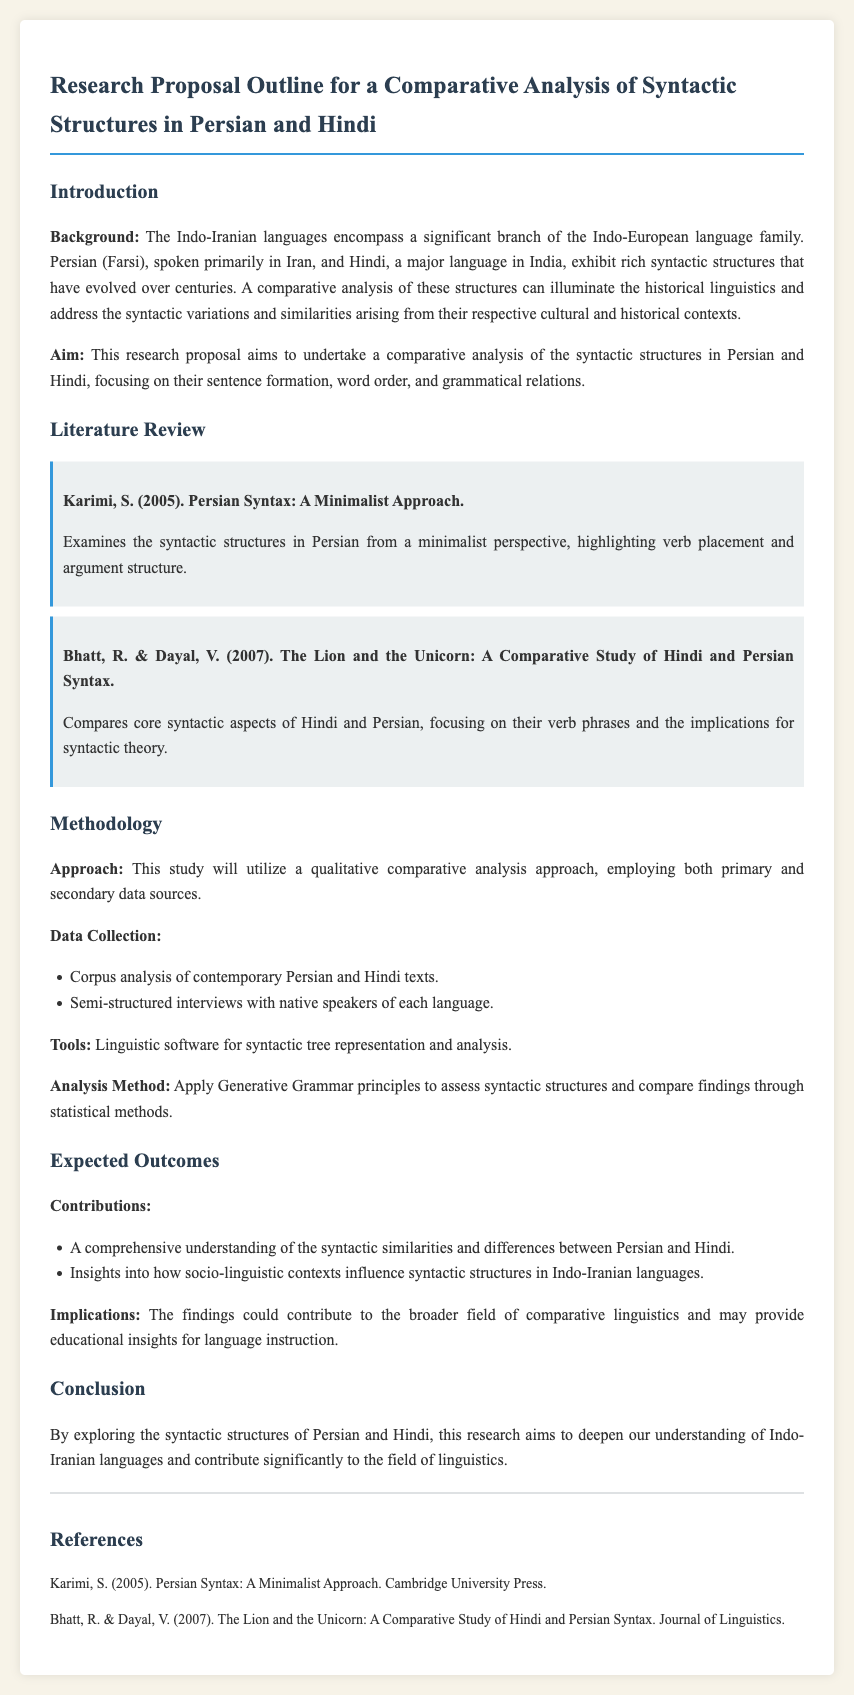What is the primary focus of the research proposal? The research proposal aims to undertake a comparative analysis of the syntactic structures in Persian and Hindi, focusing on their sentence formation, word order, and grammatical relations.
Answer: comparative analysis of the syntactic structures in Persian and Hindi Who authored the key study on Persian syntax from a minimalist perspective? The document mentions a key study authored by S. Karimi in 2005, focusing on Persian syntax from a minimalist approach.
Answer: S. Karimi What year was the study "The Lion and the Unicorn" published? The document states that the study by R. Bhatt and V. Dayal was published in 2007.
Answer: 2007 What data collection method is used besides corpus analysis? The proposal includes semi-structured interviews with native speakers of each language as a method for data collection.
Answer: semi-structured interviews What are the expected contributions outlined in the expected outcomes? The expected contributions include a comprehensive understanding of the syntactic similarities and differences between Persian and Hindi and insights into socio-linguistic contexts.
Answer: comprehensive understanding of the syntactic similarities and differences between Persian and Hindi Which linguistic software will be employed for analysis? The methodology section mentions that linguistic software for syntactic tree representation and analysis will be used in the study.
Answer: linguistic software for syntactic tree representation and analysis What implications do the findings aim to achieve in the field of linguistics? The document states that the findings could contribute to the broader field of comparative linguistics and may provide educational insights for language instruction.
Answer: contribute to the broader field of comparative linguistics What genre of the documents is this memo considered? This memo is considered a research proposal outline focusing on a comparative analysis of syntactic structures in two languages.
Answer: research proposal outline 